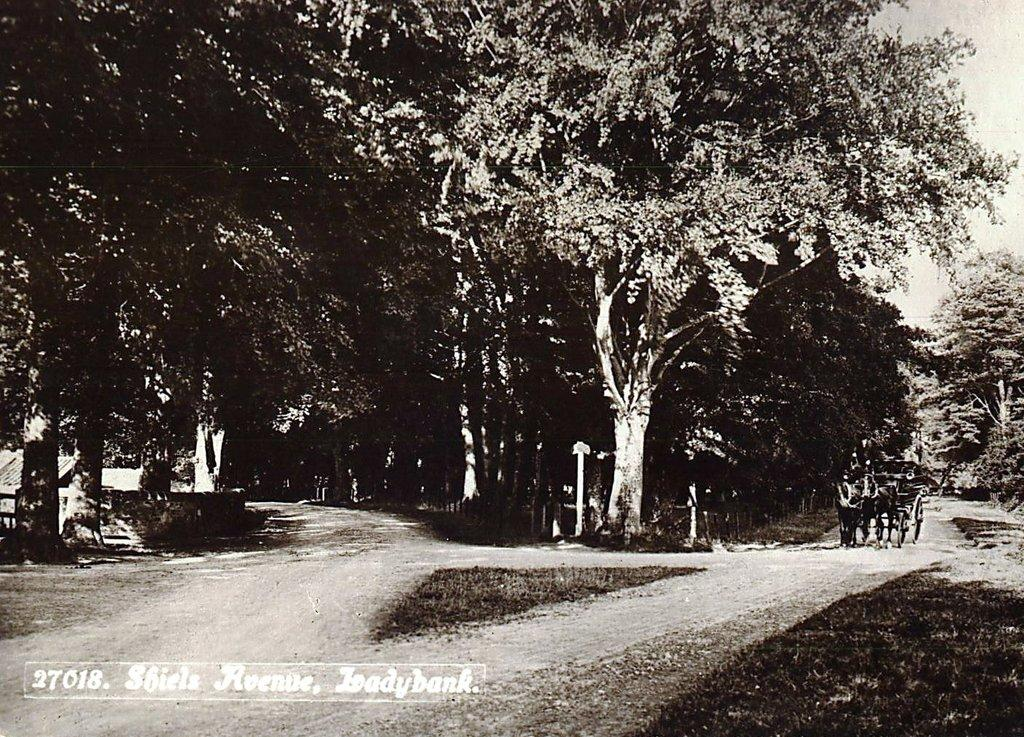What type of vegetation can be seen in the image? There are trees in the image. What activity is the person in the image engaged in? There is a person riding a tango in the image. What type of structures are visible in the background of the image? There are houses visible in the background of the image. What type of tools does the carpenter use in the image? There is no carpenter present in the image, so it is not possible to answer that question. What type of humor can be seen in the image? There is no humor depicted in the image; it shows a person riding a tango and trees in the background. 